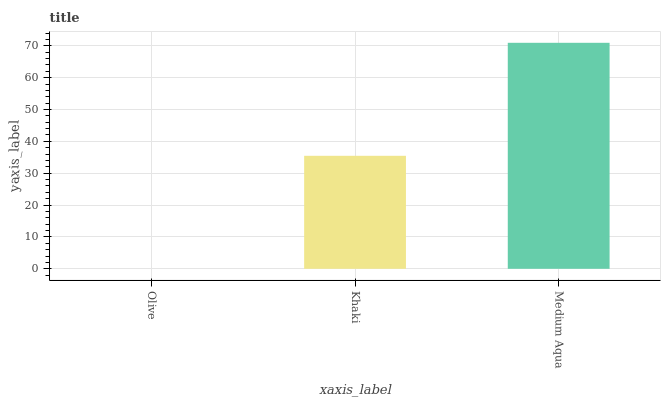Is Medium Aqua the maximum?
Answer yes or no. Yes. Is Khaki the minimum?
Answer yes or no. No. Is Khaki the maximum?
Answer yes or no. No. Is Khaki greater than Olive?
Answer yes or no. Yes. Is Olive less than Khaki?
Answer yes or no. Yes. Is Olive greater than Khaki?
Answer yes or no. No. Is Khaki less than Olive?
Answer yes or no. No. Is Khaki the high median?
Answer yes or no. Yes. Is Khaki the low median?
Answer yes or no. Yes. Is Medium Aqua the high median?
Answer yes or no. No. Is Medium Aqua the low median?
Answer yes or no. No. 